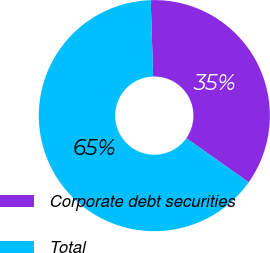<chart> <loc_0><loc_0><loc_500><loc_500><pie_chart><fcel>Corporate debt securities<fcel>Total<nl><fcel>35.29%<fcel>64.71%<nl></chart> 